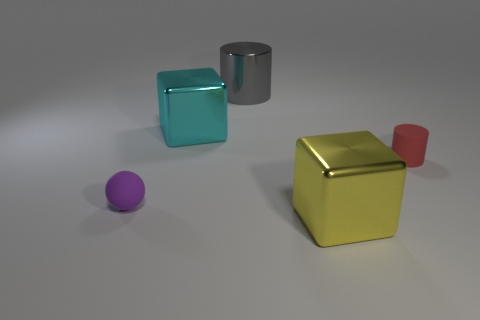What number of metallic objects are blocks or large green blocks?
Your answer should be very brief. 2. What number of brown things are either small cylinders or small balls?
Give a very brief answer. 0. Is the color of the large thing that is behind the large cyan block the same as the tiny rubber cylinder?
Keep it short and to the point. No. Is the tiny purple sphere made of the same material as the big gray thing?
Your answer should be very brief. No. Is the number of big metal objects in front of the tiny purple object the same as the number of rubber spheres that are on the right side of the cyan shiny thing?
Keep it short and to the point. No. There is a yellow object that is the same shape as the large cyan object; what material is it?
Give a very brief answer. Metal. What is the shape of the small matte thing behind the matte thing left of the metal block that is behind the matte cylinder?
Provide a short and direct response. Cylinder. Is the number of gray shiny cylinders that are on the right side of the yellow metallic cube greater than the number of purple things?
Your answer should be compact. No. Does the tiny matte object left of the large yellow shiny block have the same shape as the gray metallic object?
Offer a very short reply. No. What material is the big cube that is left of the yellow metallic block?
Ensure brevity in your answer.  Metal. 